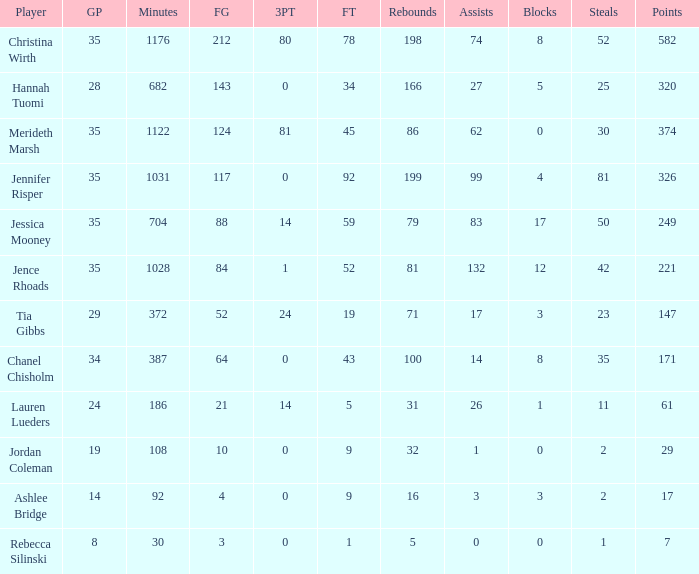For how long did Jordan Coleman play? 108.0. 